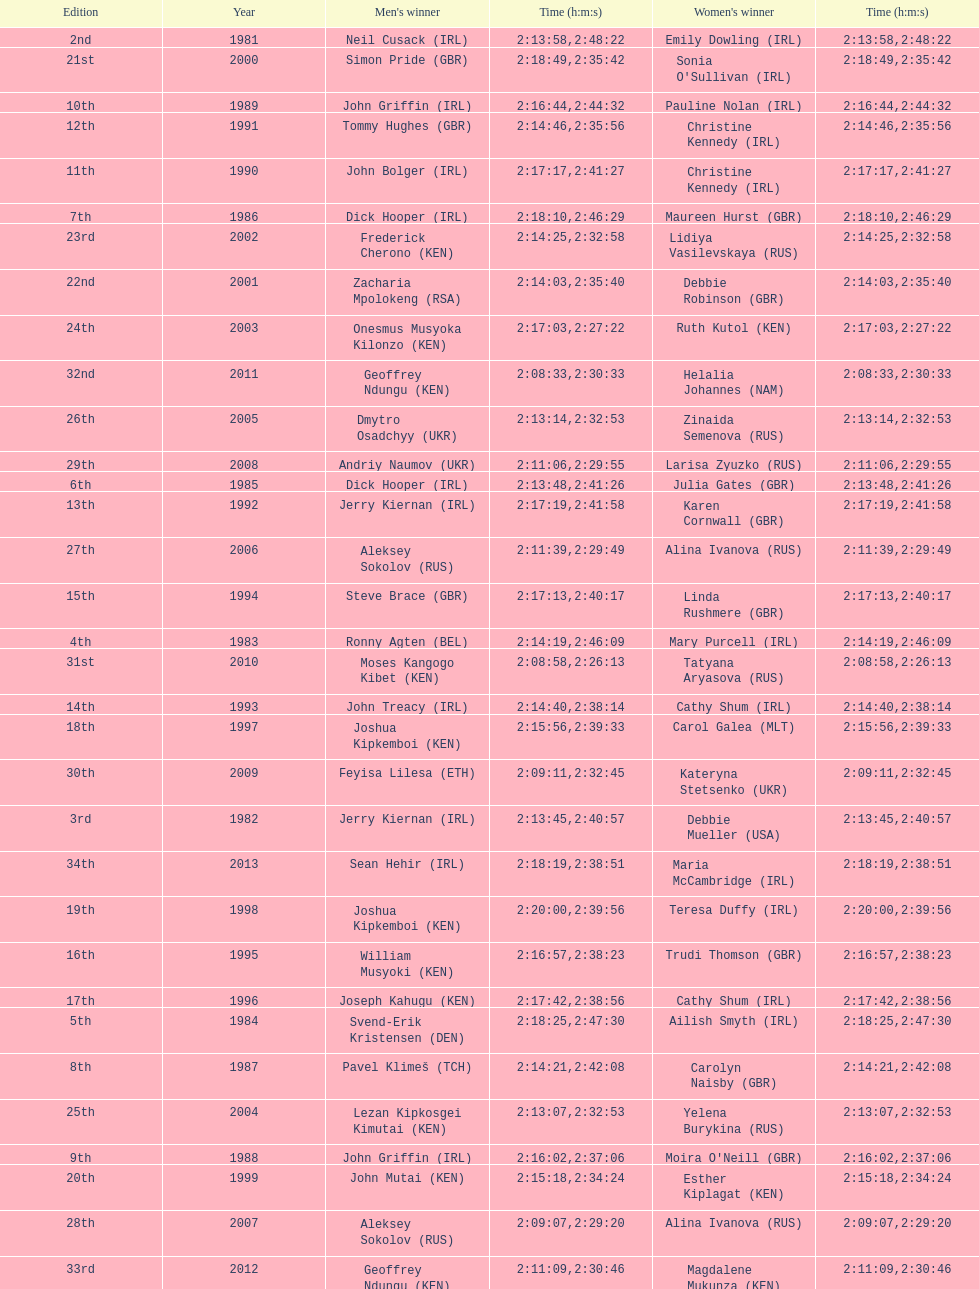Who had the most amount of time out of all the runners? Maria McCambridge (IRL). Would you be able to parse every entry in this table? {'header': ['Edition', 'Year', "Men's winner", 'Time (h:m:s)', "Women's winner", 'Time (h:m:s)'], 'rows': [['2nd', '1981', 'Neil Cusack\xa0(IRL)', '2:13:58', 'Emily Dowling\xa0(IRL)', '2:48:22'], ['21st', '2000', 'Simon Pride\xa0(GBR)', '2:18:49', "Sonia O'Sullivan\xa0(IRL)", '2:35:42'], ['10th', '1989', 'John Griffin\xa0(IRL)', '2:16:44', 'Pauline Nolan\xa0(IRL)', '2:44:32'], ['12th', '1991', 'Tommy Hughes\xa0(GBR)', '2:14:46', 'Christine Kennedy\xa0(IRL)', '2:35:56'], ['11th', '1990', 'John Bolger\xa0(IRL)', '2:17:17', 'Christine Kennedy\xa0(IRL)', '2:41:27'], ['7th', '1986', 'Dick Hooper\xa0(IRL)', '2:18:10', 'Maureen Hurst\xa0(GBR)', '2:46:29'], ['23rd', '2002', 'Frederick Cherono\xa0(KEN)', '2:14:25', 'Lidiya Vasilevskaya\xa0(RUS)', '2:32:58'], ['22nd', '2001', 'Zacharia Mpolokeng\xa0(RSA)', '2:14:03', 'Debbie Robinson\xa0(GBR)', '2:35:40'], ['24th', '2003', 'Onesmus Musyoka Kilonzo\xa0(KEN)', '2:17:03', 'Ruth Kutol\xa0(KEN)', '2:27:22'], ['32nd', '2011', 'Geoffrey Ndungu\xa0(KEN)', '2:08:33', 'Helalia Johannes\xa0(NAM)', '2:30:33'], ['26th', '2005', 'Dmytro Osadchyy\xa0(UKR)', '2:13:14', 'Zinaida Semenova\xa0(RUS)', '2:32:53'], ['29th', '2008', 'Andriy Naumov\xa0(UKR)', '2:11:06', 'Larisa Zyuzko\xa0(RUS)', '2:29:55'], ['6th', '1985', 'Dick Hooper\xa0(IRL)', '2:13:48', 'Julia Gates\xa0(GBR)', '2:41:26'], ['13th', '1992', 'Jerry Kiernan\xa0(IRL)', '2:17:19', 'Karen Cornwall\xa0(GBR)', '2:41:58'], ['27th', '2006', 'Aleksey Sokolov\xa0(RUS)', '2:11:39', 'Alina Ivanova\xa0(RUS)', '2:29:49'], ['15th', '1994', 'Steve Brace\xa0(GBR)', '2:17:13', 'Linda Rushmere\xa0(GBR)', '2:40:17'], ['4th', '1983', 'Ronny Agten\xa0(BEL)', '2:14:19', 'Mary Purcell\xa0(IRL)', '2:46:09'], ['31st', '2010', 'Moses Kangogo Kibet\xa0(KEN)', '2:08:58', 'Tatyana Aryasova\xa0(RUS)', '2:26:13'], ['14th', '1993', 'John Treacy\xa0(IRL)', '2:14:40', 'Cathy Shum\xa0(IRL)', '2:38:14'], ['18th', '1997', 'Joshua Kipkemboi\xa0(KEN)', '2:15:56', 'Carol Galea\xa0(MLT)', '2:39:33'], ['30th', '2009', 'Feyisa Lilesa\xa0(ETH)', '2:09:11', 'Kateryna Stetsenko\xa0(UKR)', '2:32:45'], ['3rd', '1982', 'Jerry Kiernan\xa0(IRL)', '2:13:45', 'Debbie Mueller\xa0(USA)', '2:40:57'], ['34th', '2013', 'Sean Hehir\xa0(IRL)', '2:18:19', 'Maria McCambridge\xa0(IRL)', '2:38:51'], ['19th', '1998', 'Joshua Kipkemboi\xa0(KEN)', '2:20:00', 'Teresa Duffy\xa0(IRL)', '2:39:56'], ['16th', '1995', 'William Musyoki\xa0(KEN)', '2:16:57', 'Trudi Thomson\xa0(GBR)', '2:38:23'], ['17th', '1996', 'Joseph Kahugu\xa0(KEN)', '2:17:42', 'Cathy Shum\xa0(IRL)', '2:38:56'], ['5th', '1984', 'Svend-Erik Kristensen\xa0(DEN)', '2:18:25', 'Ailish Smyth\xa0(IRL)', '2:47:30'], ['8th', '1987', 'Pavel Klimeš\xa0(TCH)', '2:14:21', 'Carolyn Naisby\xa0(GBR)', '2:42:08'], ['25th', '2004', 'Lezan Kipkosgei Kimutai\xa0(KEN)', '2:13:07', 'Yelena Burykina\xa0(RUS)', '2:32:53'], ['9th', '1988', 'John Griffin\xa0(IRL)', '2:16:02', "Moira O'Neill\xa0(GBR)", '2:37:06'], ['20th', '1999', 'John Mutai\xa0(KEN)', '2:15:18', 'Esther Kiplagat\xa0(KEN)', '2:34:24'], ['28th', '2007', 'Aleksey Sokolov\xa0(RUS)', '2:09:07', 'Alina Ivanova\xa0(RUS)', '2:29:20'], ['33rd', '2012', 'Geoffrey Ndungu\xa0(KEN)', '2:11:09', 'Magdalene Mukunza\xa0(KEN)', '2:30:46'], ['1st', '1980', 'Dick Hooper\xa0(IRL)', '2:16:14', 'Carey May\xa0(IRL)', '2:42:11']]} 